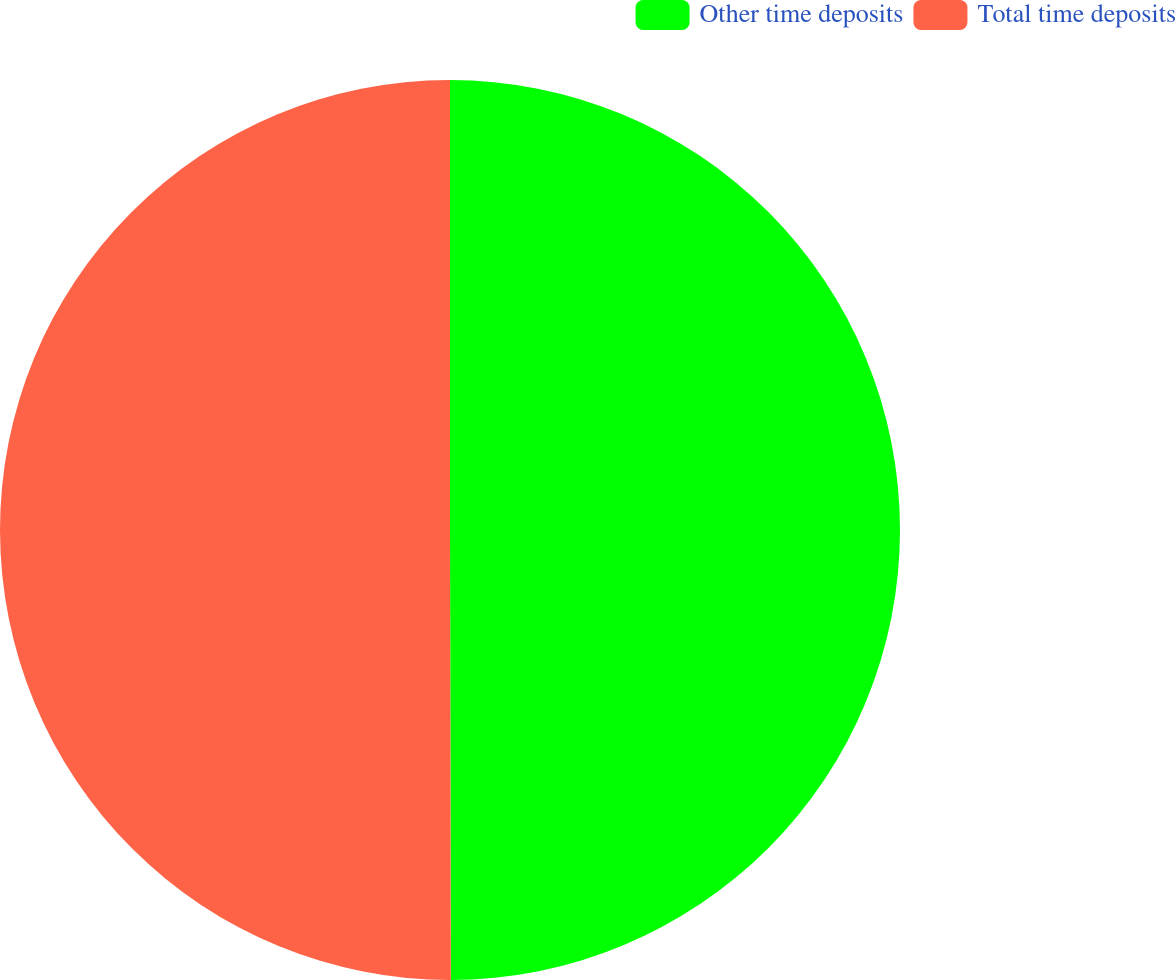<chart> <loc_0><loc_0><loc_500><loc_500><pie_chart><fcel>Other time deposits<fcel>Total time deposits<nl><fcel>49.97%<fcel>50.03%<nl></chart> 